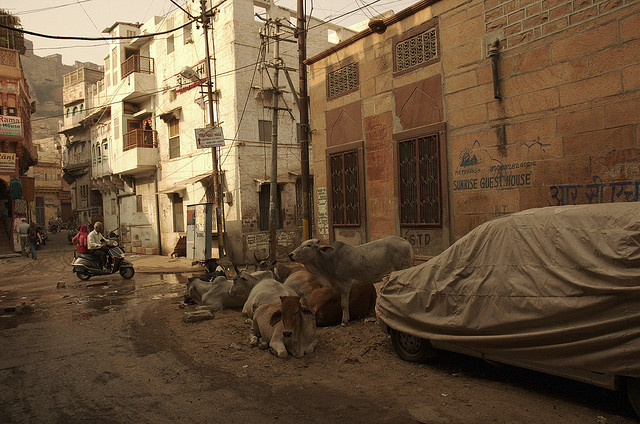What details can you tell me about the architecture seen in this image? The architecture in the image features modest, multi-story buildings with flat roofs and a mix of brick and plaster exteriors. Some buildings have decorative elements, such as tiles and colored facades, which suggests a local influence. The electrical wires and poles suggest a densely populated area with functional, utilitarian infrastructure. 